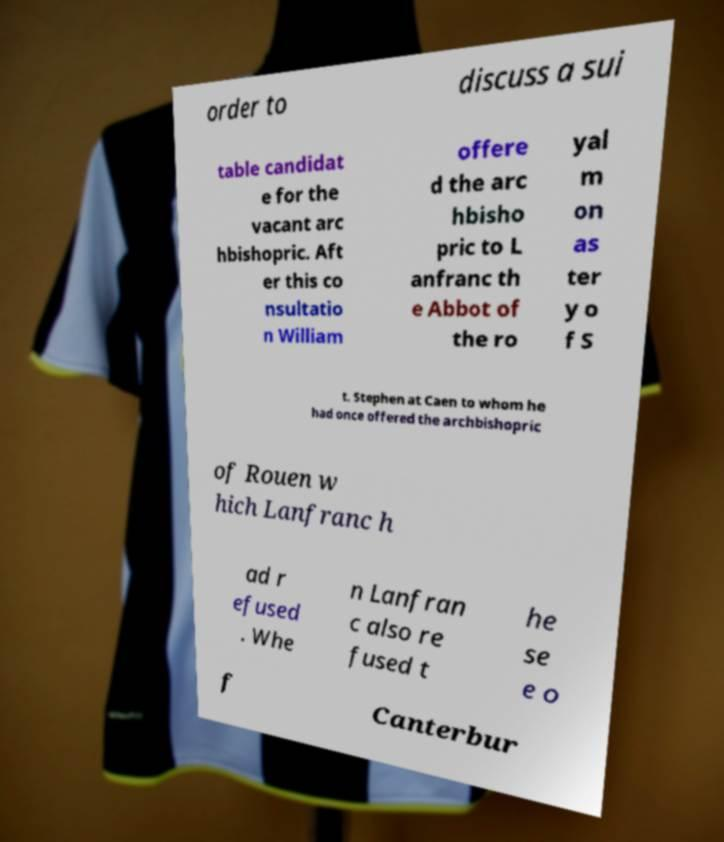Please read and relay the text visible in this image. What does it say? order to discuss a sui table candidat e for the vacant arc hbishopric. Aft er this co nsultatio n William offere d the arc hbisho pric to L anfranc th e Abbot of the ro yal m on as ter y o f S t. Stephen at Caen to whom he had once offered the archbishopric of Rouen w hich Lanfranc h ad r efused . Whe n Lanfran c also re fused t he se e o f Canterbur 